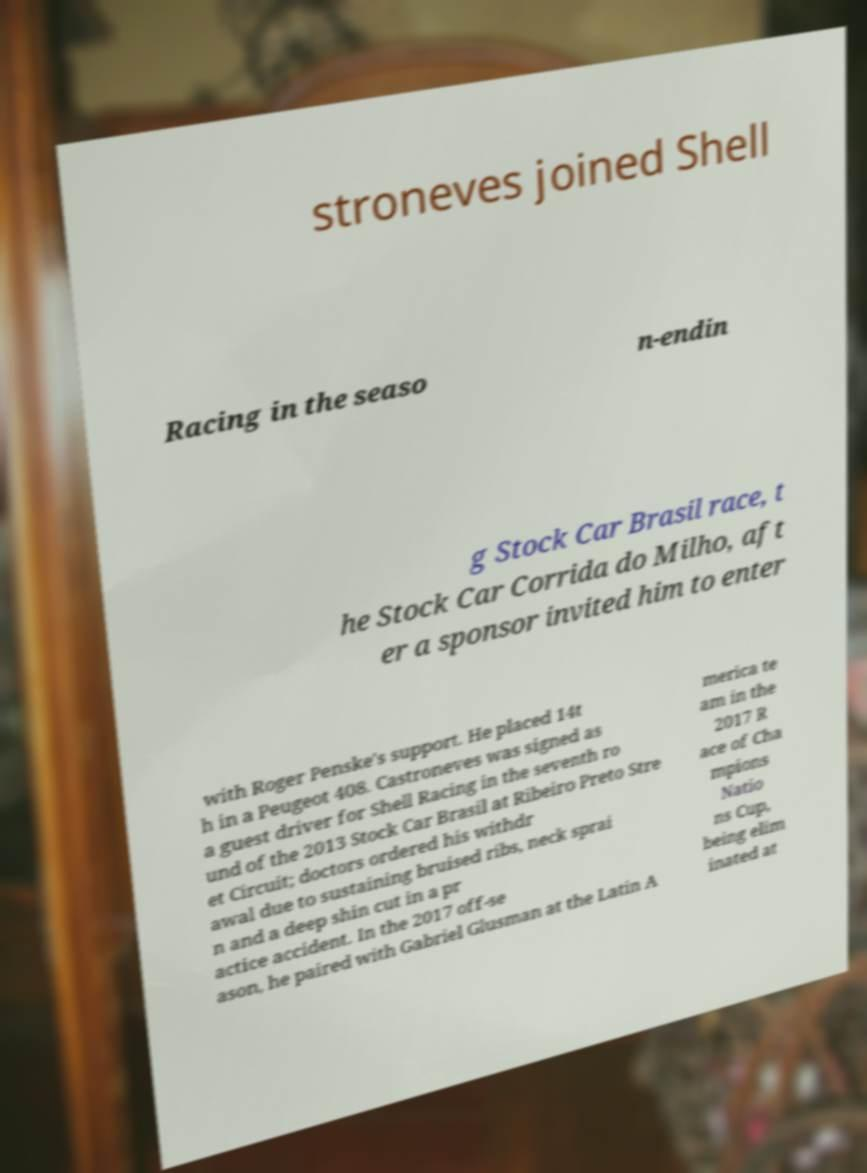What messages or text are displayed in this image? I need them in a readable, typed format. stroneves joined Shell Racing in the seaso n-endin g Stock Car Brasil race, t he Stock Car Corrida do Milho, aft er a sponsor invited him to enter with Roger Penske's support. He placed 14t h in a Peugeot 408. Castroneves was signed as a guest driver for Shell Racing in the seventh ro und of the 2013 Stock Car Brasil at Ribeiro Preto Stre et Circuit; doctors ordered his withdr awal due to sustaining bruised ribs, neck sprai n and a deep shin cut in a pr actice accident. In the 2017 off-se ason, he paired with Gabriel Glusman at the Latin A merica te am in the 2017 R ace of Cha mpions Natio ns Cup, being elim inated at 